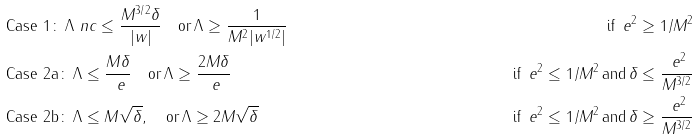Convert formula to latex. <formula><loc_0><loc_0><loc_500><loc_500>& \text {Case 1} \colon \, \Lambda \ n c \leq \frac { M ^ { 3 / 2 } \delta } { | w | } \quad \text {or} \, \Lambda \geq \frac { 1 } { M ^ { 2 } | w ^ { 1 / 2 } | } \quad & \text {if} \, \ e ^ { 2 } \geq 1 / M ^ { 2 } \\ & \text {Case 2a} \colon \, \Lambda \leq \frac { M \delta } { \ e } \quad \text {or} \, \Lambda \geq \frac { 2 M \delta } { \ e } \quad & \text {if} \, \ e ^ { 2 } \leq 1 / M ^ { 2 } \, \text {and} \, \delta \leq \frac { \ e ^ { 2 } } { M ^ { 3 / 2 } } \\ & \text {Case 2b} \colon \, \Lambda \leq M \sqrt { \delta } , \quad \text {or} \, \Lambda \geq 2 M \sqrt { \delta } \quad & \text {if} \, \ e ^ { 2 } \leq 1 / M ^ { 2 } \, \text {and} \, \delta \geq \frac { \ e ^ { 2 } } { M ^ { 3 / 2 } }</formula> 